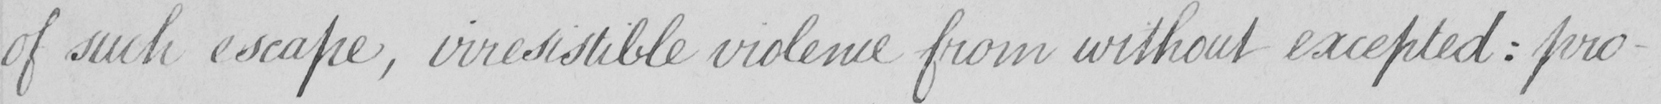What is written in this line of handwriting? of such escape , irresistible violence from without excepted :  pro- 